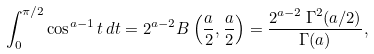<formula> <loc_0><loc_0><loc_500><loc_500>\int _ { 0 } ^ { \pi / 2 } \cos ^ { a - 1 } t \, d t = 2 ^ { a - 2 } B \left ( \frac { a } { 2 } , \frac { a } { 2 } \right ) = \frac { 2 ^ { a - 2 } \, \Gamma ^ { 2 } ( a / 2 ) } { \Gamma ( a ) } ,</formula> 